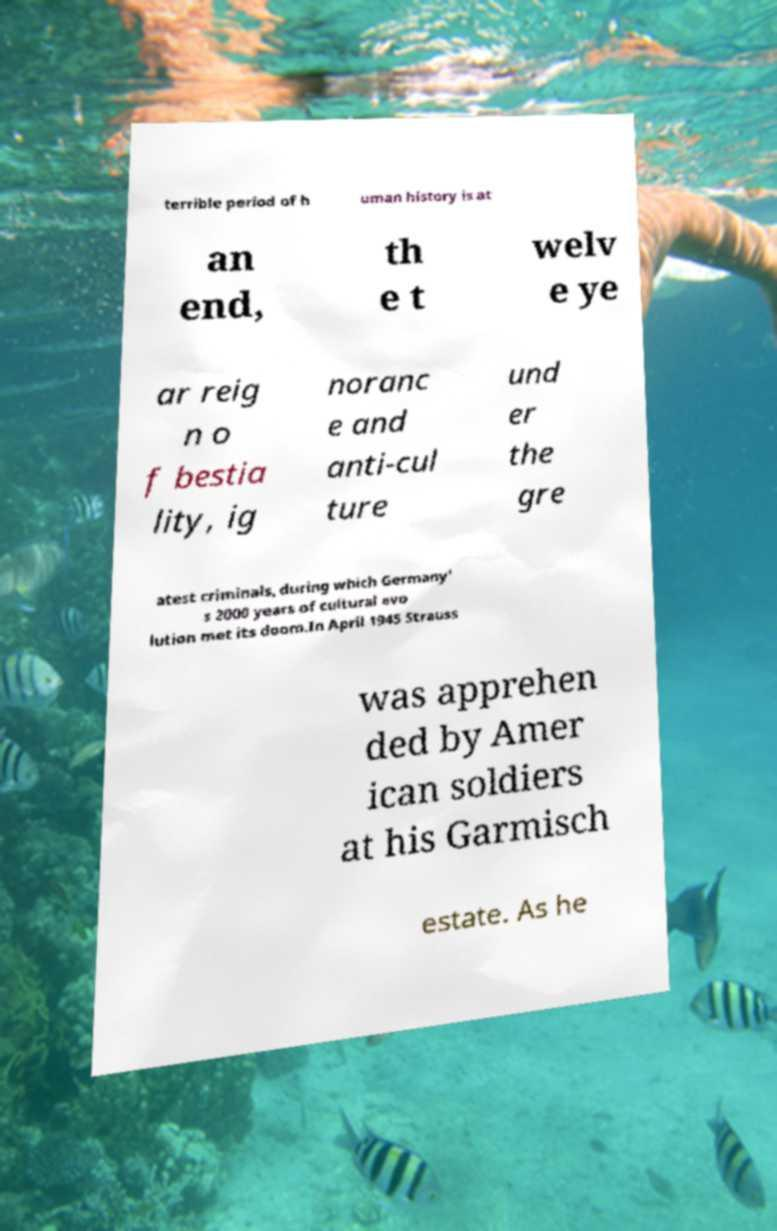Could you assist in decoding the text presented in this image and type it out clearly? terrible period of h uman history is at an end, th e t welv e ye ar reig n o f bestia lity, ig noranc e and anti-cul ture und er the gre atest criminals, during which Germany' s 2000 years of cultural evo lution met its doom.In April 1945 Strauss was apprehen ded by Amer ican soldiers at his Garmisch estate. As he 